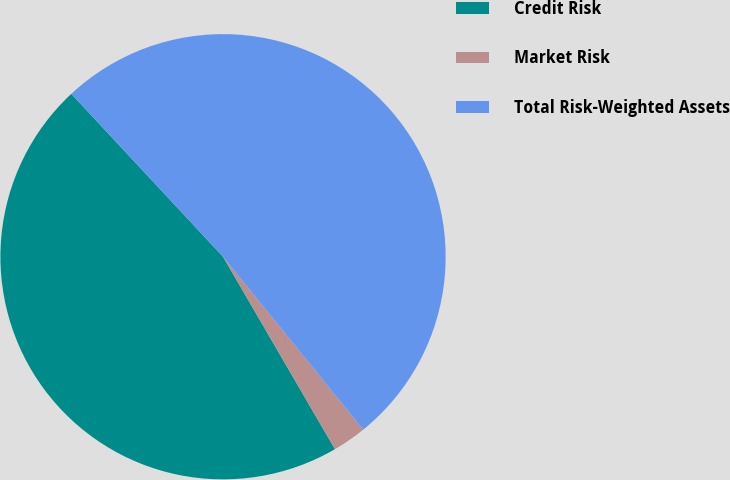<chart> <loc_0><loc_0><loc_500><loc_500><pie_chart><fcel>Credit Risk<fcel>Market Risk<fcel>Total Risk-Weighted Assets<nl><fcel>46.45%<fcel>2.46%<fcel>51.09%<nl></chart> 